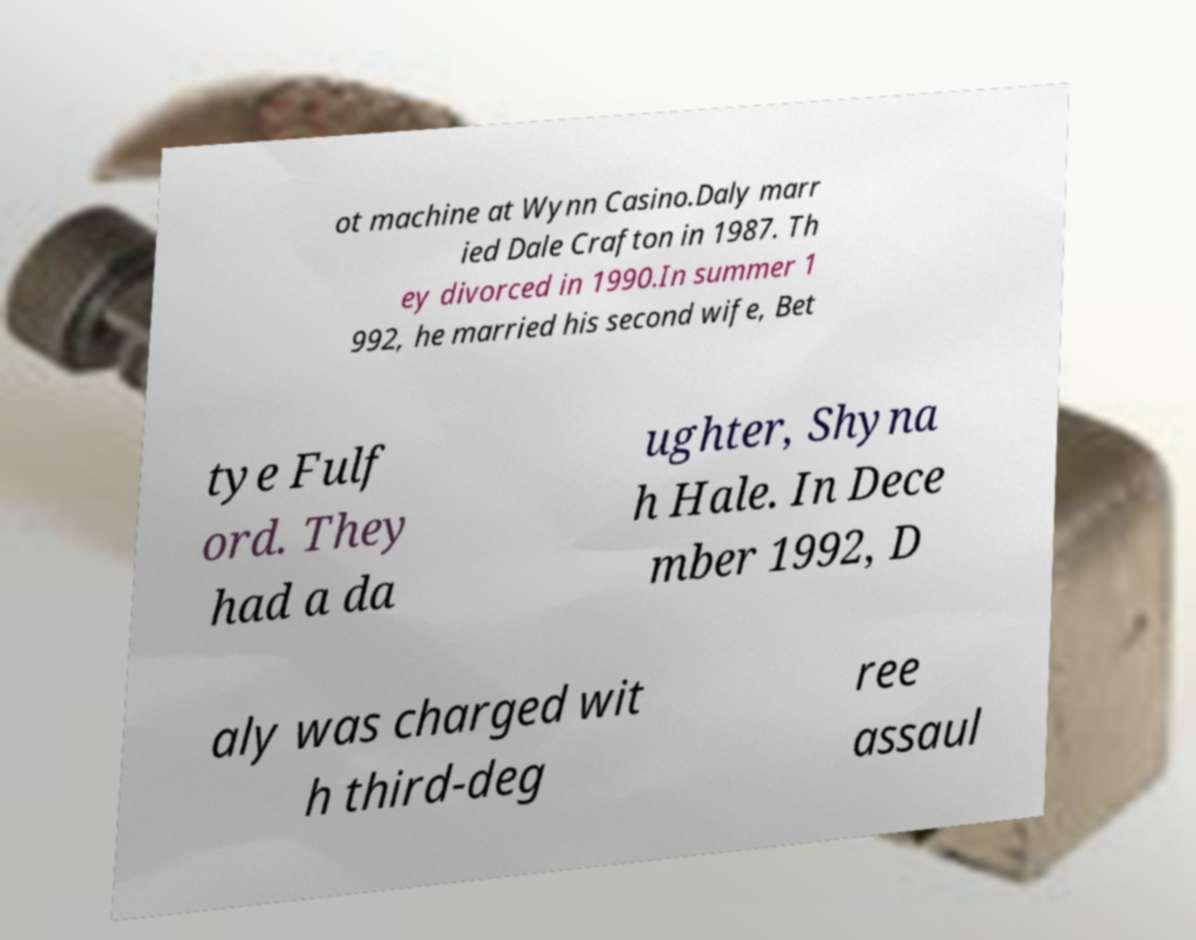What messages or text are displayed in this image? I need them in a readable, typed format. ot machine at Wynn Casino.Daly marr ied Dale Crafton in 1987. Th ey divorced in 1990.In summer 1 992, he married his second wife, Bet tye Fulf ord. They had a da ughter, Shyna h Hale. In Dece mber 1992, D aly was charged wit h third-deg ree assaul 